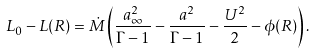Convert formula to latex. <formula><loc_0><loc_0><loc_500><loc_500>L _ { 0 } - L ( R ) = \dot { M } \left ( \frac { a ^ { 2 } _ { \infty } } { \Gamma - 1 } - \frac { a ^ { 2 } } { \Gamma - 1 } - \frac { U ^ { 2 } } { 2 } - \phi ( R ) \right ) .</formula> 